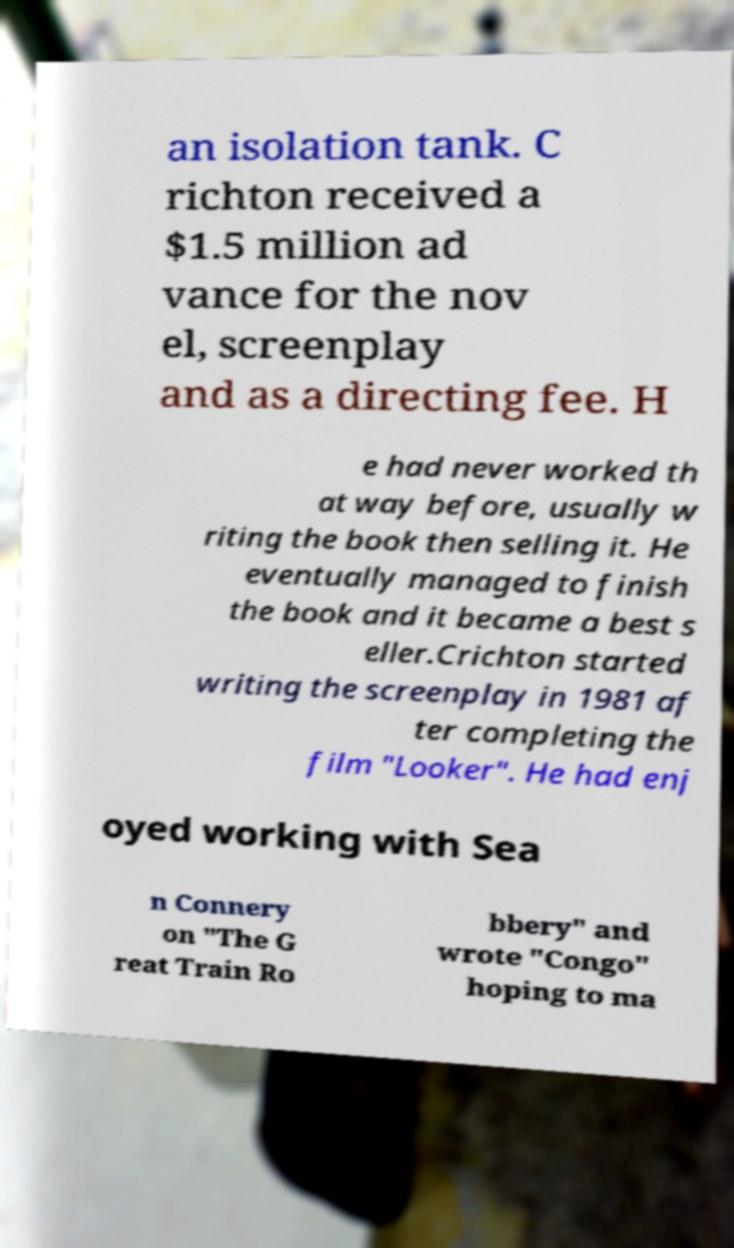I need the written content from this picture converted into text. Can you do that? an isolation tank. C richton received a $1.5 million ad vance for the nov el, screenplay and as a directing fee. H e had never worked th at way before, usually w riting the book then selling it. He eventually managed to finish the book and it became a best s eller.Crichton started writing the screenplay in 1981 af ter completing the film "Looker". He had enj oyed working with Sea n Connery on "The G reat Train Ro bbery" and wrote "Congo" hoping to ma 